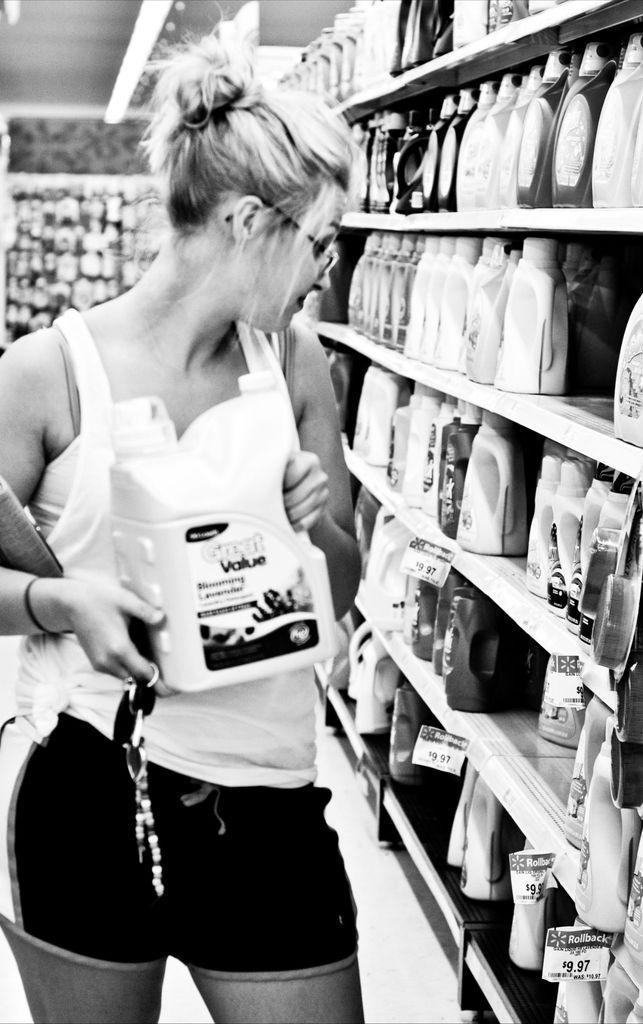Can you describe this image briefly? On the left side, there is a woman in white color t-shirt, holding a bottle with both hands and standing. Beside her, there are bottles arranged on the shelves. In the background, there is a light attached to the roof and there are other objects. 